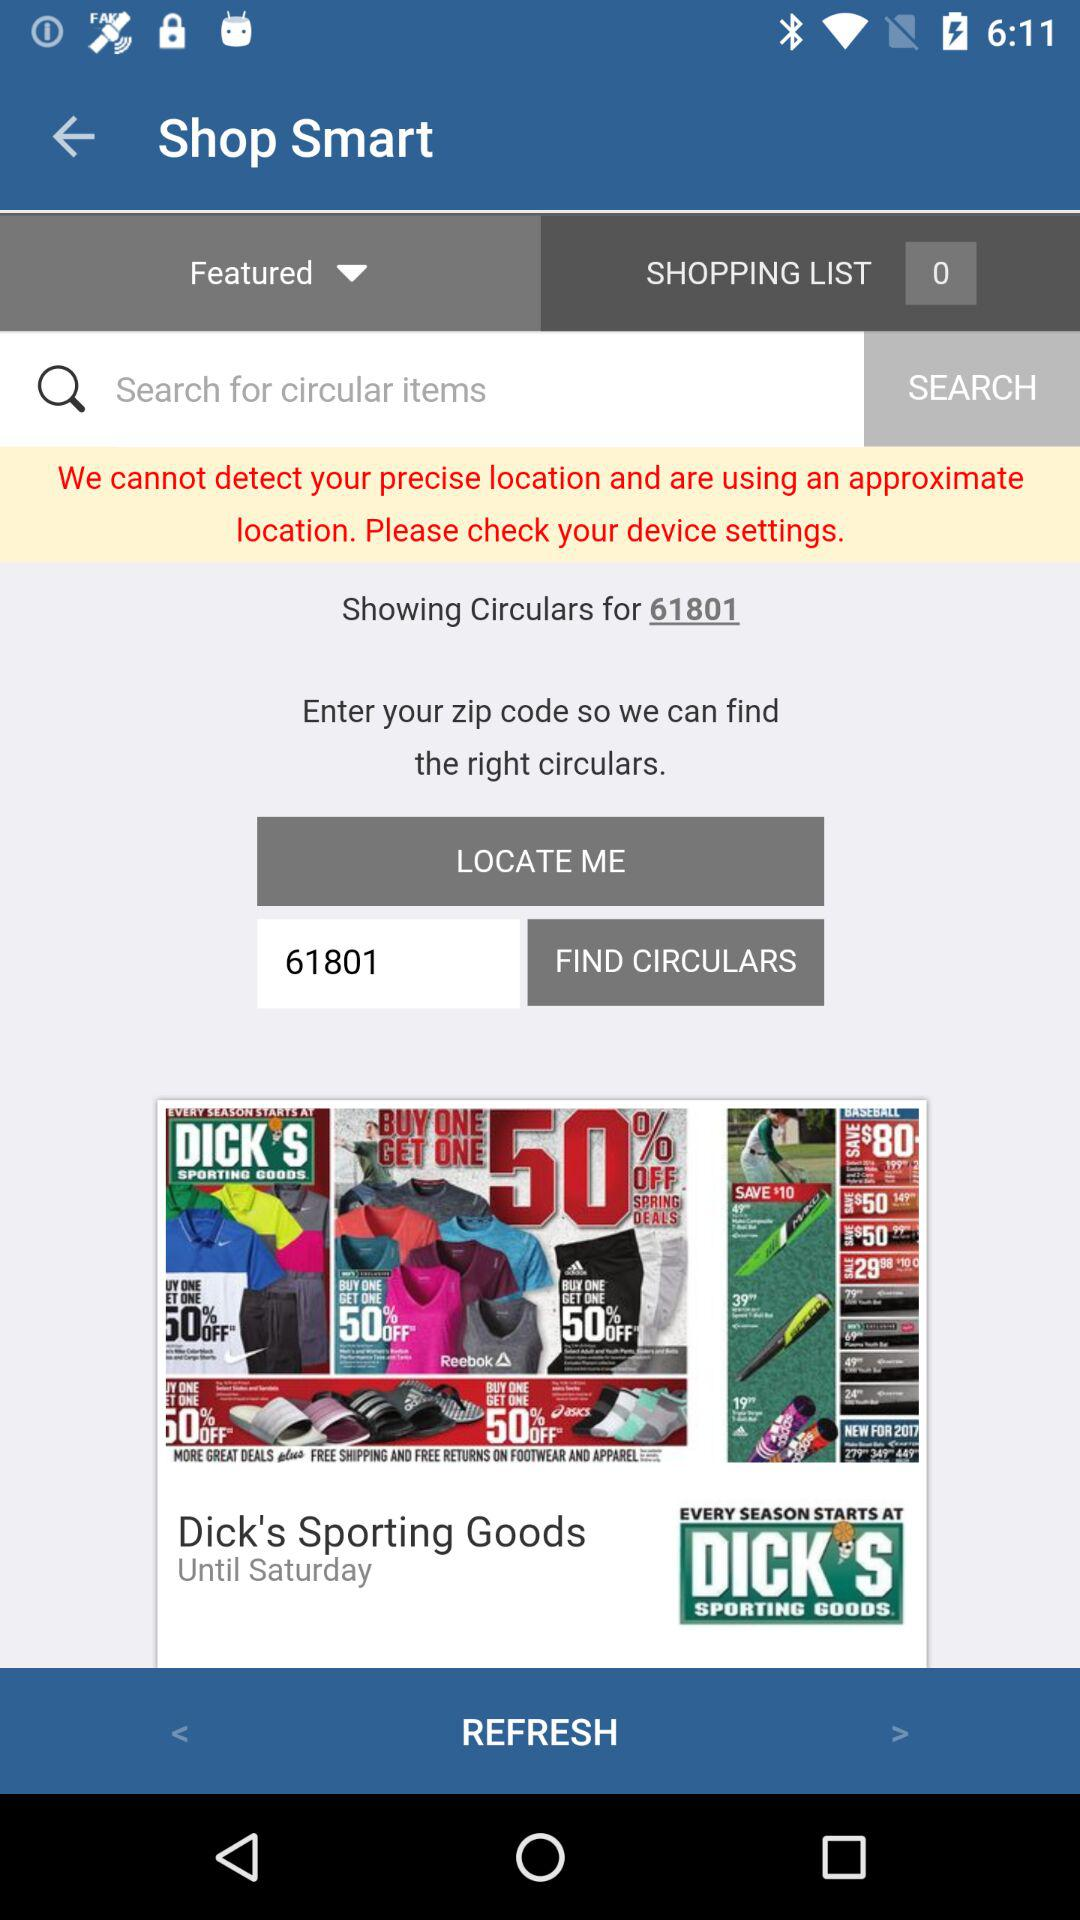What is entered into the search bar?
When the provided information is insufficient, respond with <no answer>. <no answer> 